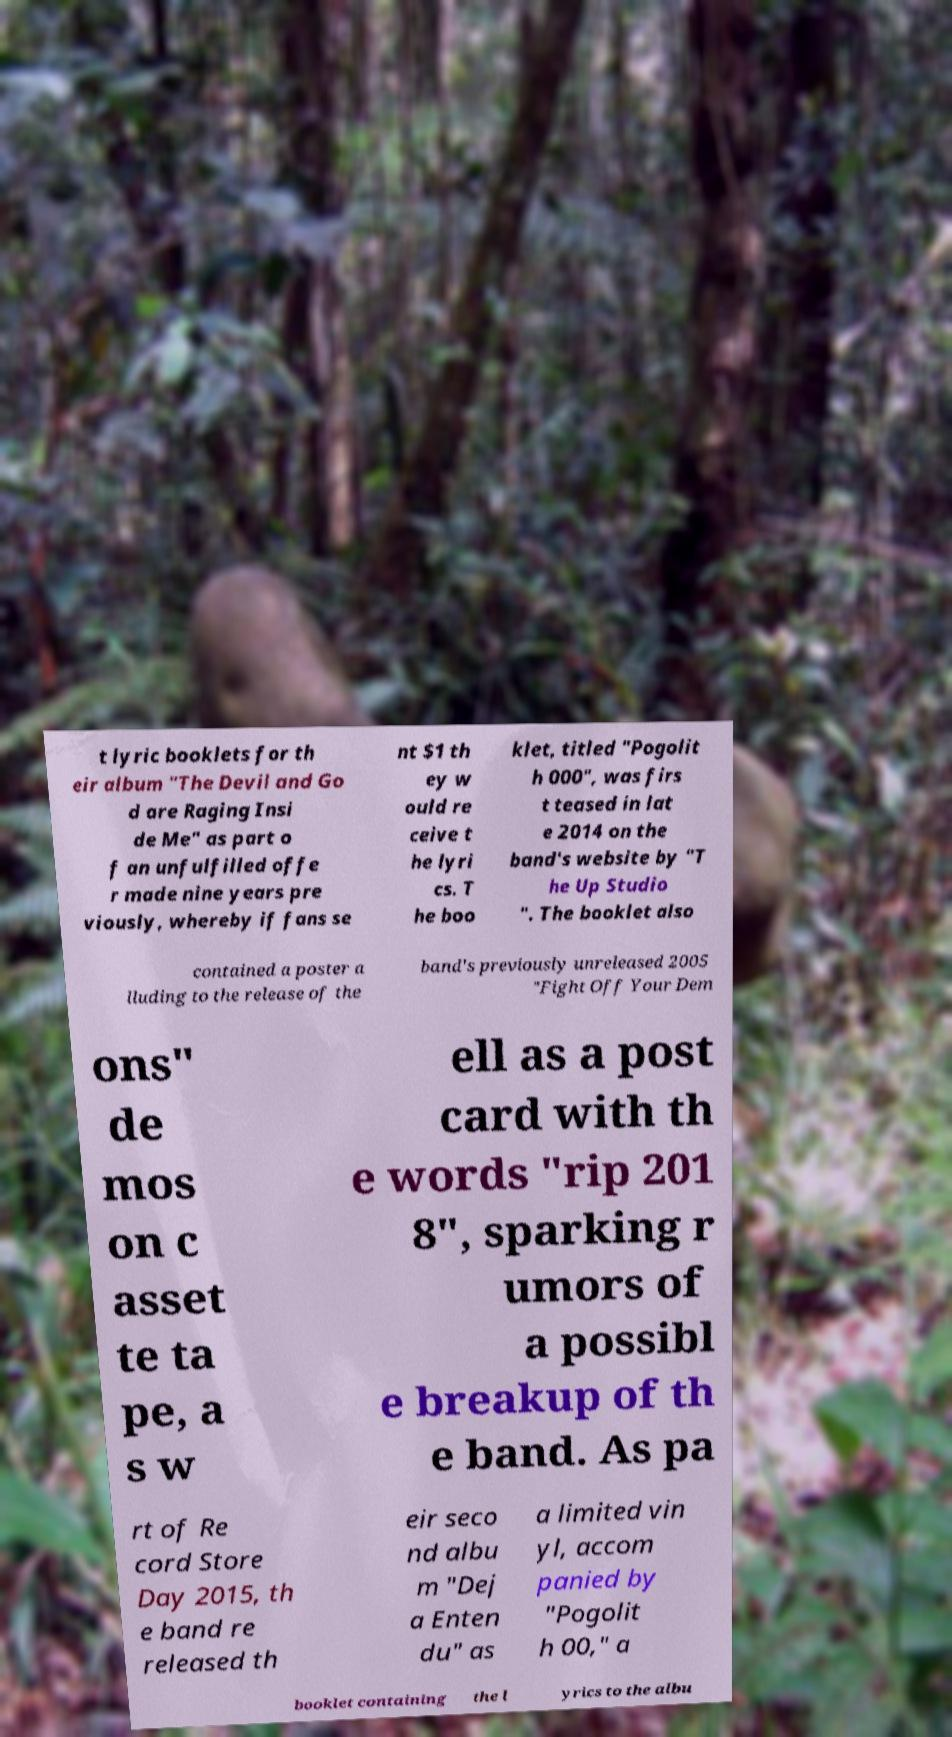Can you read and provide the text displayed in the image?This photo seems to have some interesting text. Can you extract and type it out for me? t lyric booklets for th eir album "The Devil and Go d are Raging Insi de Me" as part o f an unfulfilled offe r made nine years pre viously, whereby if fans se nt $1 th ey w ould re ceive t he lyri cs. T he boo klet, titled "Pogolit h 000", was firs t teased in lat e 2014 on the band's website by "T he Up Studio ". The booklet also contained a poster a lluding to the release of the band's previously unreleased 2005 "Fight Off Your Dem ons" de mos on c asset te ta pe, a s w ell as a post card with th e words "rip 201 8", sparking r umors of a possibl e breakup of th e band. As pa rt of Re cord Store Day 2015, th e band re released th eir seco nd albu m "Dej a Enten du" as a limited vin yl, accom panied by "Pogolit h 00," a booklet containing the l yrics to the albu 